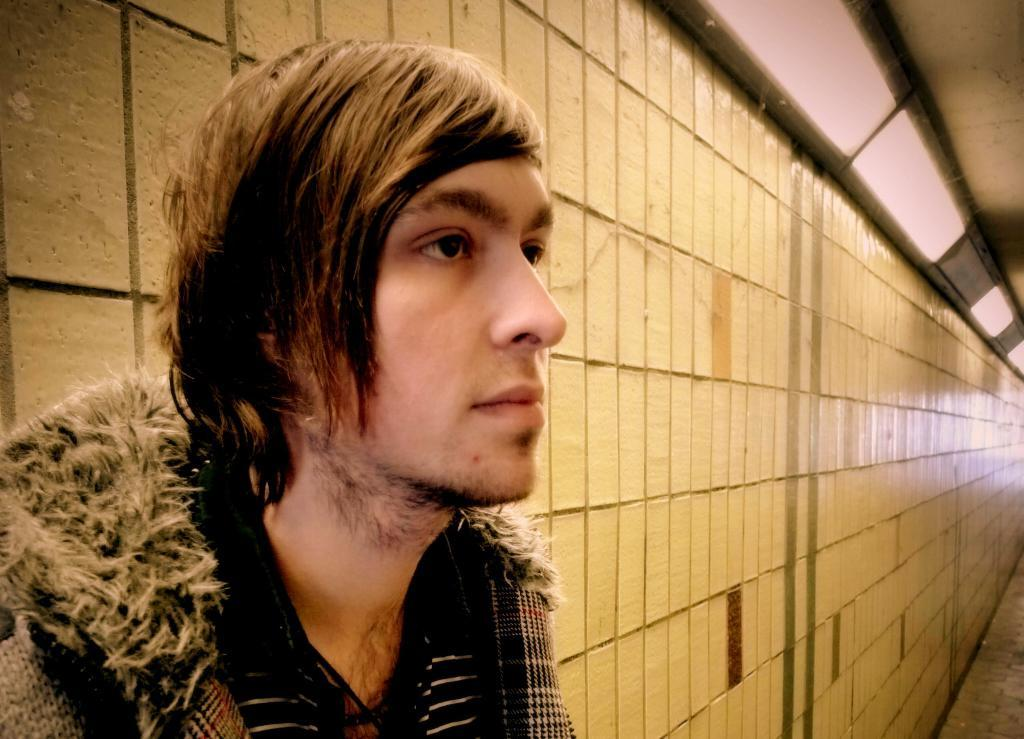Who is present in the image? There is a man in the image. What is located behind the man in the image? There is a wall in the image. What can be seen attached to the wall in the image? There are lights attached to the wall in the image. Can you see a baby holding a pin in the image? There is no baby or pin present in the image. 